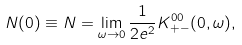Convert formula to latex. <formula><loc_0><loc_0><loc_500><loc_500>N ( 0 ) \equiv N = \lim _ { \omega \rightarrow 0 } \frac { 1 } { 2 e ^ { 2 } } K ^ { 0 0 } _ { + - } ( { 0 } , \omega ) ,</formula> 